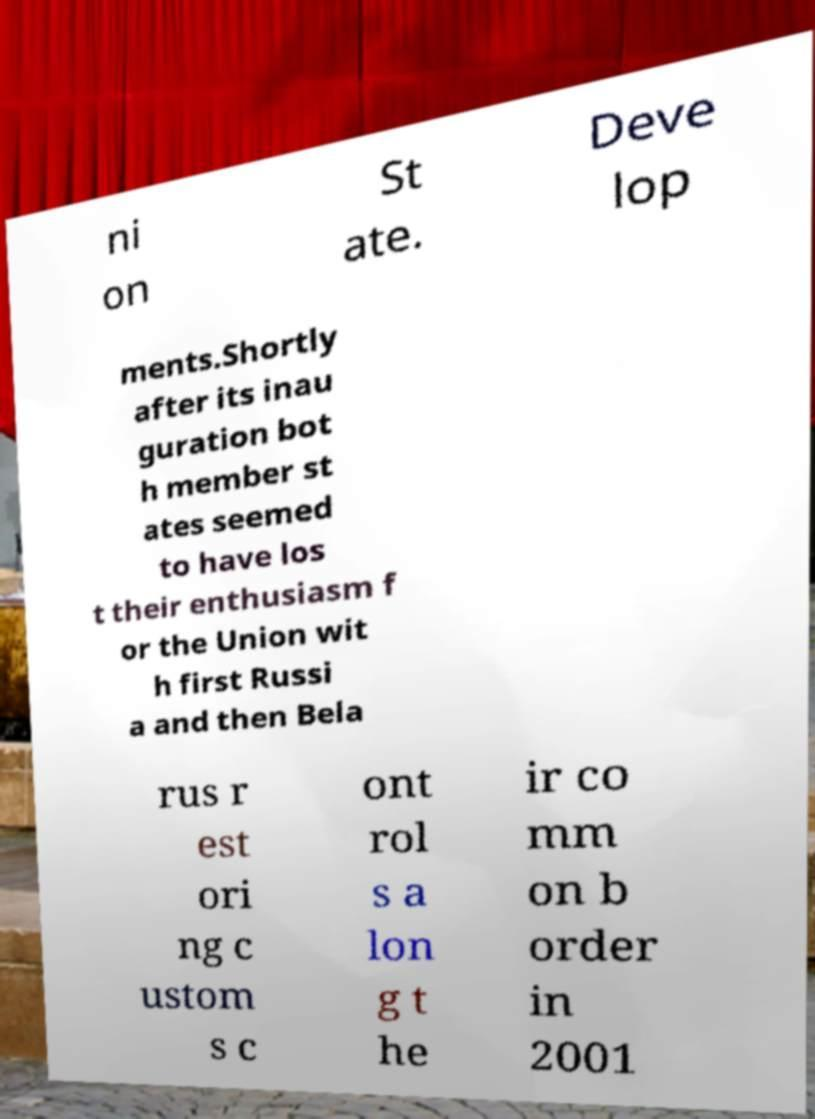There's text embedded in this image that I need extracted. Can you transcribe it verbatim? ni on St ate. Deve lop ments.Shortly after its inau guration bot h member st ates seemed to have los t their enthusiasm f or the Union wit h first Russi a and then Bela rus r est ori ng c ustom s c ont rol s a lon g t he ir co mm on b order in 2001 